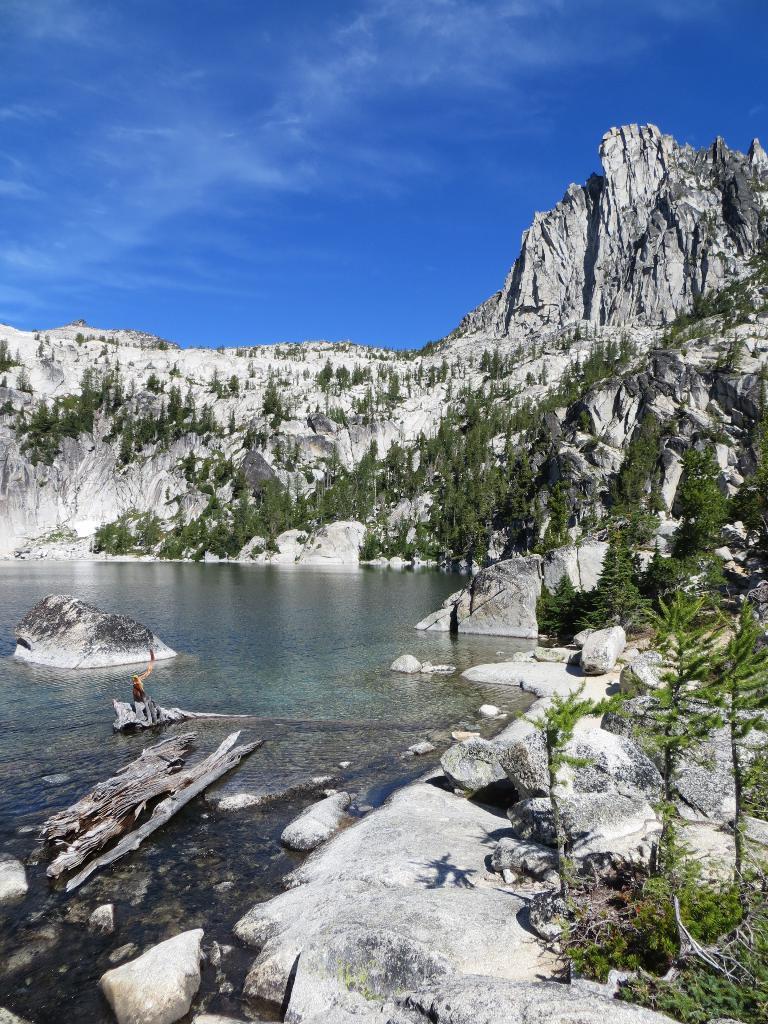How would you summarize this image in a sentence or two? In this picture we can see wooden trunks in the water, in the background we can see few trees, rocks and clouds. 